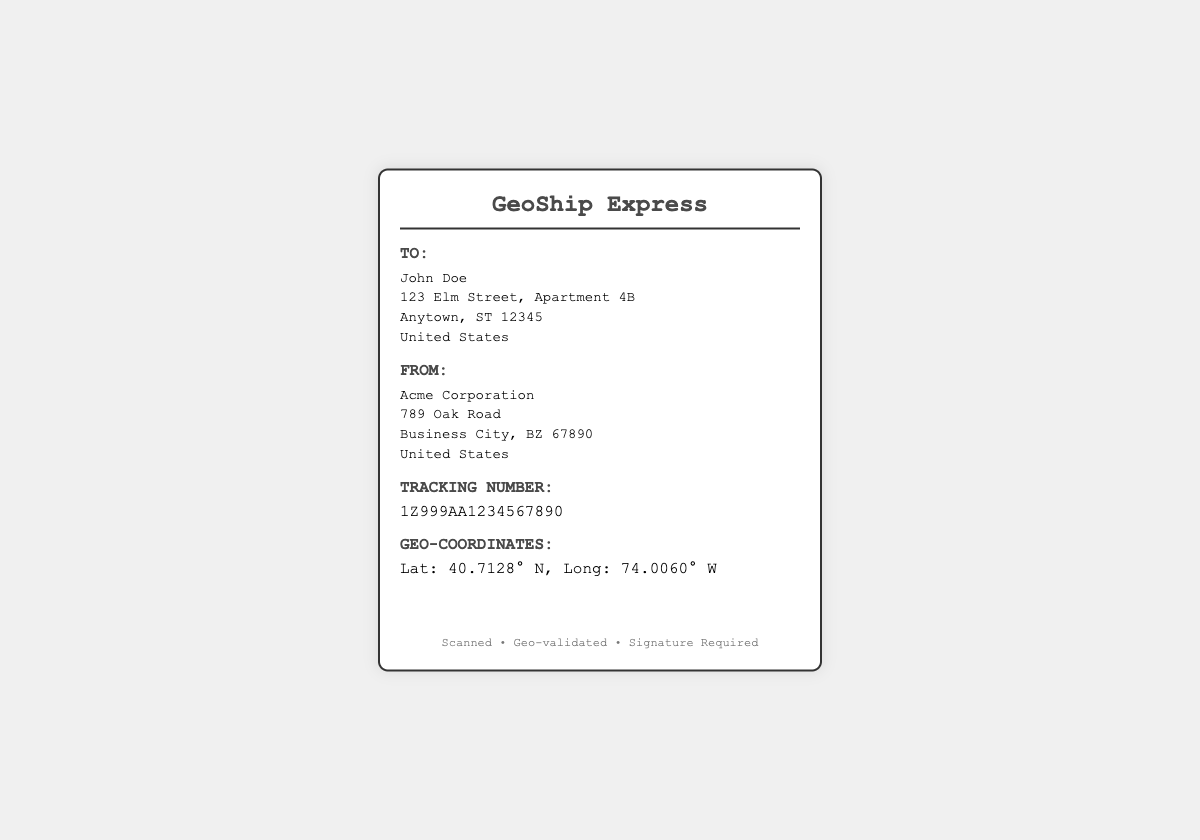What is the recipient's name? The recipient's name is specified in the "To:" section of the label.
Answer: John Doe What is the sender's company name? The sender's company name is listed in the "From:" section of the label.
Answer: Acme Corporation What is the tracking number provided? The tracking number is indicated in a dedicated section of the label.
Answer: 1Z999AA1234567890 What are the geo-coordinates mentioned? The geo-coordinates are given in a specific section dedicated to geographical information.
Answer: Lat: 40.7128° N, Long: 74.0060° W What does the footer state about the shipment? The footer contains specific statements regarding the shipment process.
Answer: Scanned • Geo-validated • Signature Required How many sections are there in the label? The number of major sections indicated in the structure of the label can be counted.
Answer: 5 Which city is the sender located in? The sender's city is mentioned in the "From:" section of the label.
Answer: Business City What type of document is this? The format and content described identify the document type.
Answer: Shipping Label Is there a barcode present on the label? The presence of imagery or graphics is a key aspect of the document's design.
Answer: Yes 